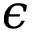<formula> <loc_0><loc_0><loc_500><loc_500>\epsilon</formula> 